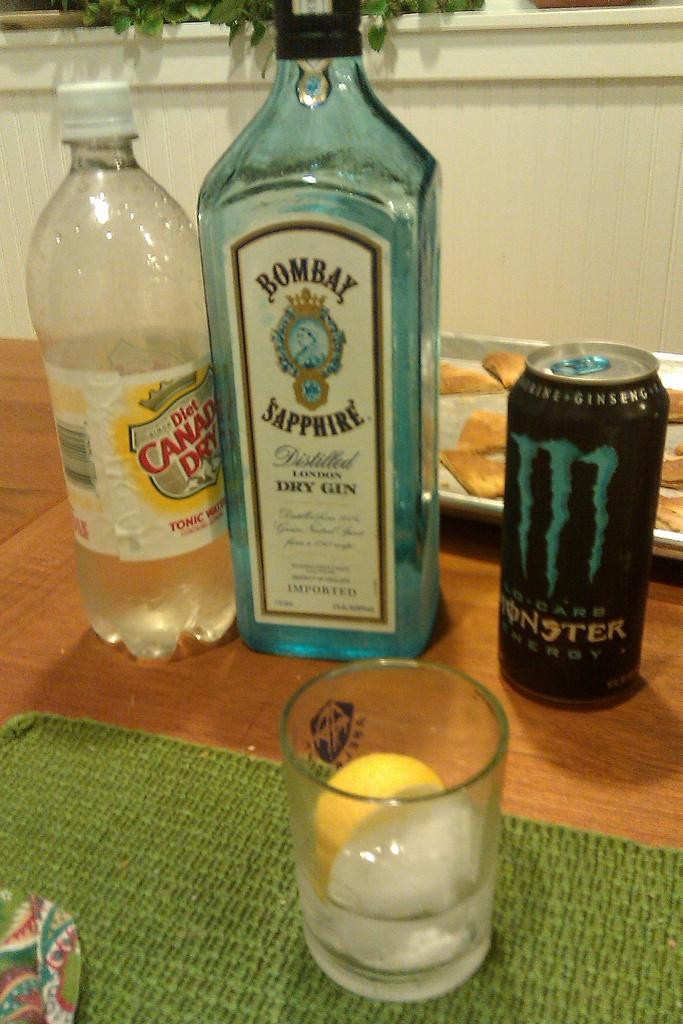<image>
Write a terse but informative summary of the picture. A bottle of Canada Dry is accompanied by a bottle of Bombay Sapphire Gin. 